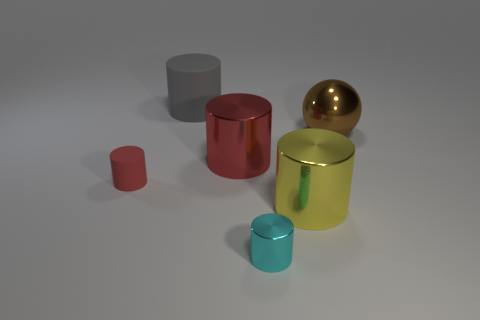Subtract all yellow cylinders. How many cylinders are left? 4 Subtract all small metallic cylinders. How many cylinders are left? 4 Subtract all purple cylinders. Subtract all cyan spheres. How many cylinders are left? 5 Add 2 big gray matte cylinders. How many objects exist? 8 Subtract all cylinders. How many objects are left? 1 Subtract all big brown shiny things. Subtract all tiny red things. How many objects are left? 4 Add 6 large red things. How many large red things are left? 7 Add 6 large red matte cylinders. How many large red matte cylinders exist? 6 Subtract 0 blue spheres. How many objects are left? 6 